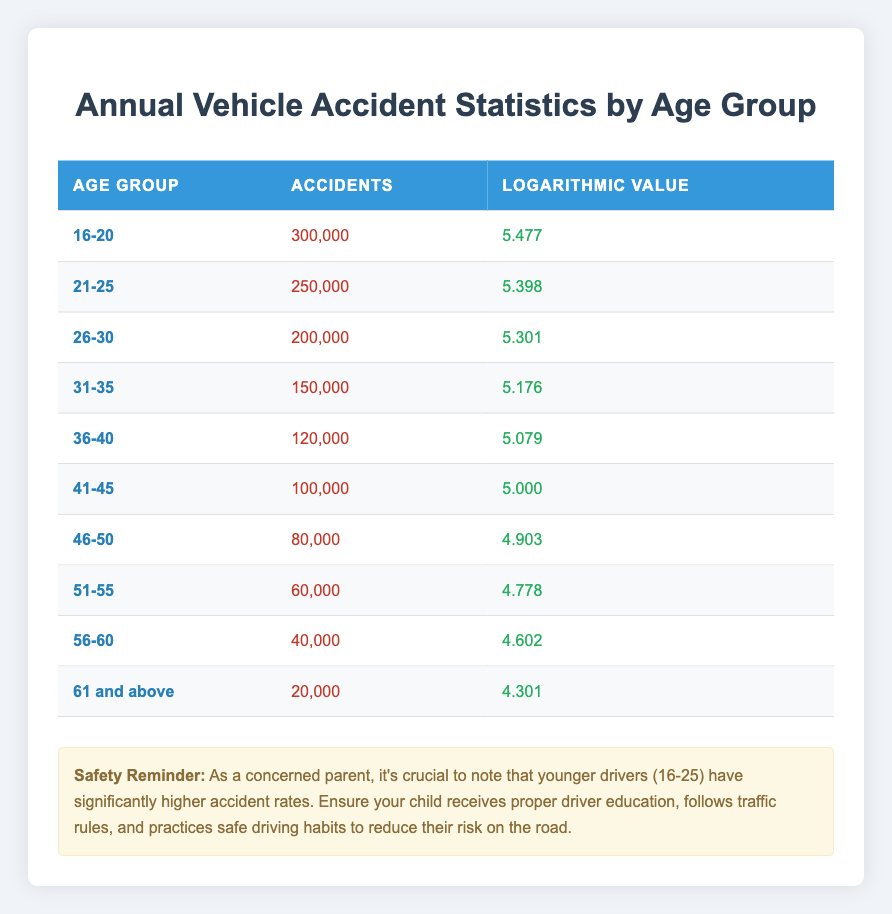What is the total number of accidents reported for drivers aged 16-20? The table indicates that there have been 300,000 accidents reported for the age group 16-20.
Answer: 300,000 Which age group has the highest number of accidents? According to the table, the age group 16-20 has the highest number of accidents, with 300,000 reported incidents.
Answer: 16-20 How many accidents were reported for drivers aged 61 and above? The table shows that there were 20,000 accidents reported for the age group aged 61 and above.
Answer: 20,000 What is the average number of accidents across all age groups? To find the average, sum the accidents for all age groups: (300,000 + 250,000 + 200,000 + 150,000 + 120,000 + 100,000 + 80,000 + 60,000 + 40,000 + 20,000) = 1,420,000. Then divide by the number of groups (10) to get the average: 1,420,000 / 10 = 142,000.
Answer: 142,000 Is it true that drivers aged 61 and above have more accidents than those aged 36-40? Based on the table, 20,000 accidents occurred for those aged 61 and above, while 120,000 were reported for the 36-40 age group. Thus, 61 and above have fewer accidents compared to 36-40.
Answer: No Which age group experiences fewer accidents, 46-50 or 51-55? In the table, the 46-50 age group has 80,000 accidents, while the 51-55 age group has 60,000. It is clear that the 51-55 age group has fewer accidents.
Answer: 51-55 What is the difference in the number of accidents between drivers aged 21-25 and those aged 31-35? The accidents for drivers aged 21-25 is 250,000 and for 31-35 it is 150,000. The difference is 250,000 - 150,000 = 100,000.
Answer: 100,000 Which age group has a logarithmic value greater than 5.3? The age groups with a logarithmic value greater than 5.3 are 16-20 (5.477), 21-25 (5.398), and 26-30 (5.301). So, there are three such groups.
Answer: Three 